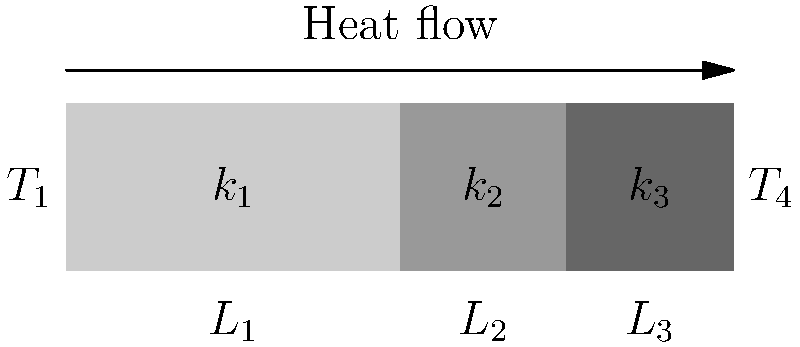Consider a composite wall consisting of three layers with thermal conductivities $k_1$, $k_2$, and $k_3$, and thicknesses $L_1$, $L_2$, and $L_3$ respectively. The temperature on the left side is $T_1$ and on the right side is $T_4$. Derive an expression for the total heat transfer rate per unit area through this composite wall in terms of the given parameters, assuming steady-state conditions and one-dimensional heat conduction. To solve this problem, we'll follow these steps:

1) In steady-state, one-dimensional heat conduction, the heat transfer rate is constant through all layers.

2) For each layer, we can apply Fourier's law of heat conduction:
   $$q = -k \frac{dT}{dx}$$
   where $q$ is the heat transfer rate per unit area, $k$ is the thermal conductivity, and $\frac{dT}{dx}$ is the temperature gradient.

3) For the first layer:
   $$q = k_1 \frac{T_1 - T_2}{L_1}$$
   where $T_2$ is the temperature at the interface between the first and second layers.

4) Similarly, for the second and third layers:
   $$q = k_2 \frac{T_2 - T_3}{L_2}$$
   $$q = k_3 \frac{T_3 - T_4}{L_3}$$

5) The total temperature difference is the sum of the temperature differences across each layer:
   $$(T_1 - T_4) = (T_1 - T_2) + (T_2 - T_3) + (T_3 - T_4)$$

6) Substituting the expressions from steps 3 and 4 into step 5:
   $$(T_1 - T_4) = \frac{qL_1}{k_1} + \frac{qL_2}{k_2} + \frac{qL_3}{k_3}$$

7) Factoring out $q$:
   $$(T_1 - T_4) = q(\frac{L_1}{k_1} + \frac{L_2}{k_2} + \frac{L_3}{k_3})$$

8) Solving for $q$:
   $$q = \frac{T_1 - T_4}{\frac{L_1}{k_1} + \frac{L_2}{k_2} + \frac{L_3}{k_3}}$$

This expression gives the total heat transfer rate per unit area through the composite wall.
Answer: $$q = \frac{T_1 - T_4}{\frac{L_1}{k_1} + \frac{L_2}{k_2} + \frac{L_3}{k_3}}$$ 